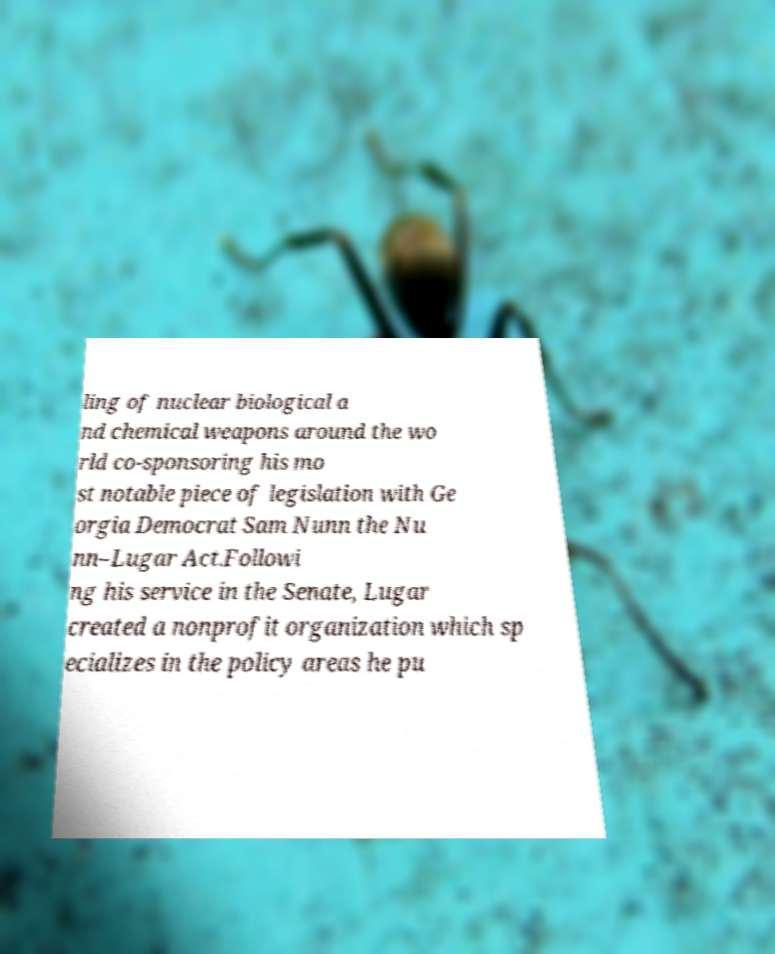For documentation purposes, I need the text within this image transcribed. Could you provide that? ling of nuclear biological a nd chemical weapons around the wo rld co-sponsoring his mo st notable piece of legislation with Ge orgia Democrat Sam Nunn the Nu nn–Lugar Act.Followi ng his service in the Senate, Lugar created a nonprofit organization which sp ecializes in the policy areas he pu 